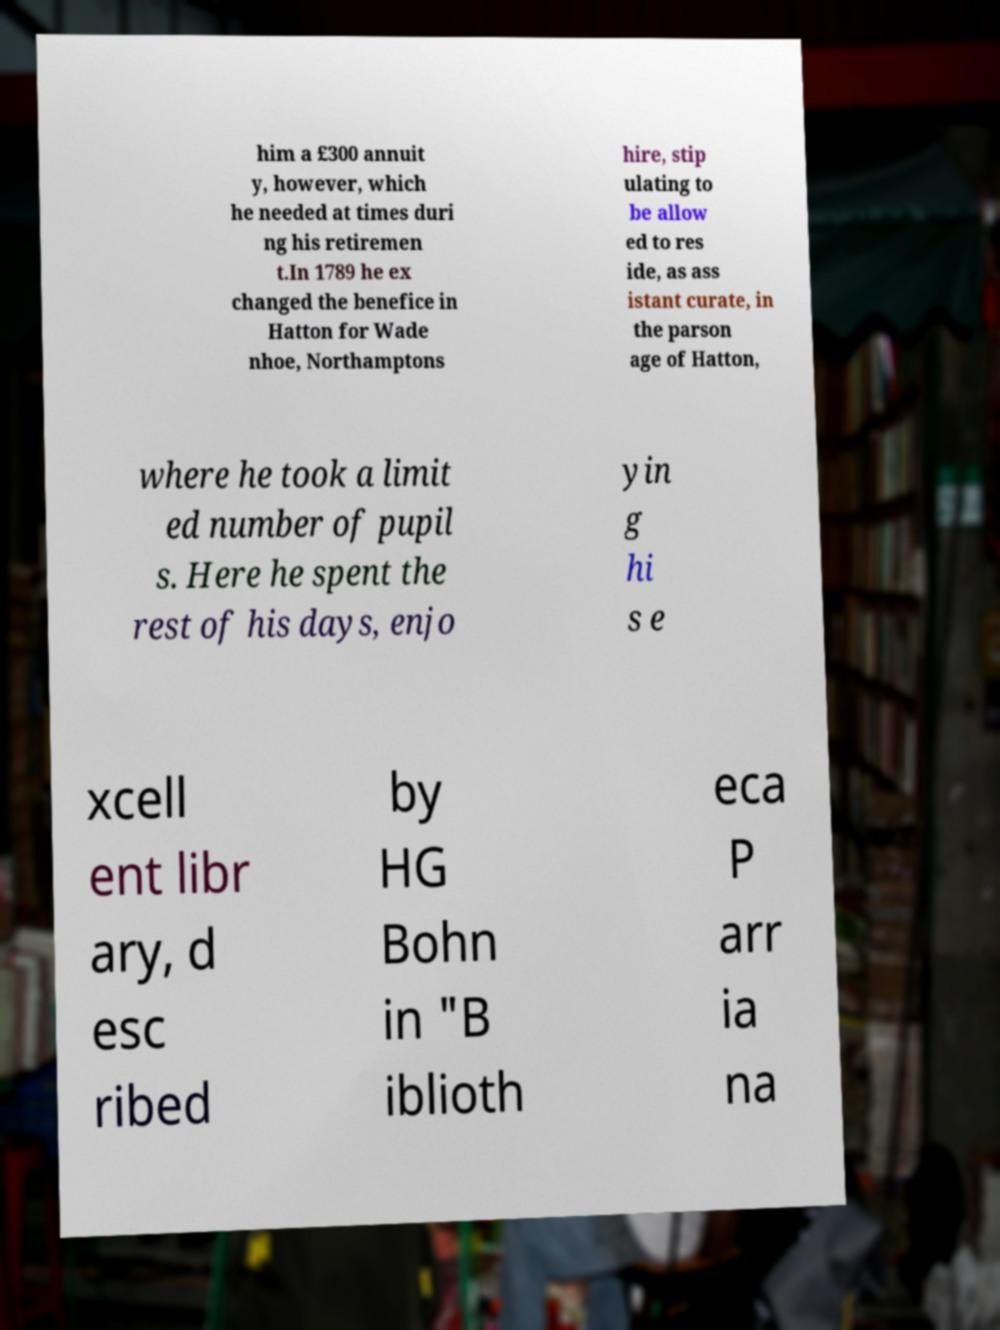Can you accurately transcribe the text from the provided image for me? him a £300 annuit y, however, which he needed at times duri ng his retiremen t.In 1789 he ex changed the benefice in Hatton for Wade nhoe, Northamptons hire, stip ulating to be allow ed to res ide, as ass istant curate, in the parson age of Hatton, where he took a limit ed number of pupil s. Here he spent the rest of his days, enjo yin g hi s e xcell ent libr ary, d esc ribed by HG Bohn in "B iblioth eca P arr ia na 